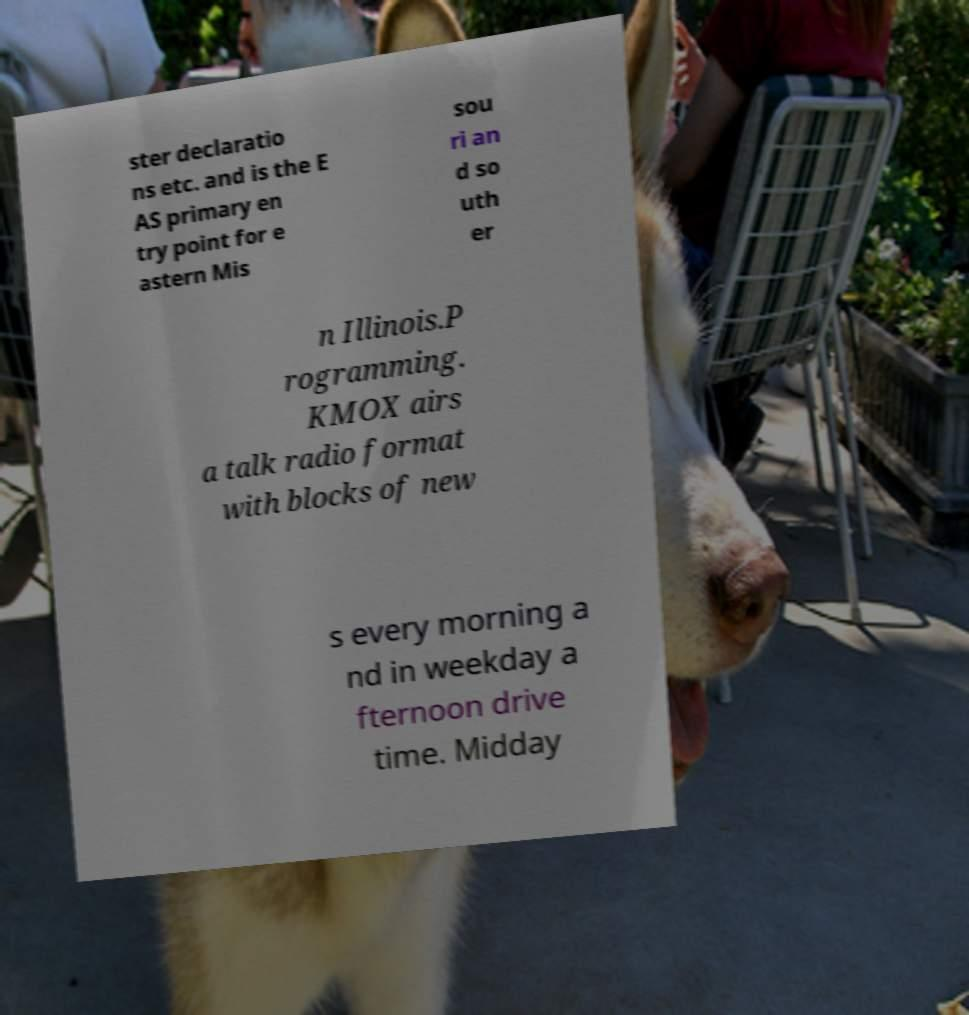Can you read and provide the text displayed in the image?This photo seems to have some interesting text. Can you extract and type it out for me? ster declaratio ns etc. and is the E AS primary en try point for e astern Mis sou ri an d so uth er n Illinois.P rogramming. KMOX airs a talk radio format with blocks of new s every morning a nd in weekday a fternoon drive time. Midday 